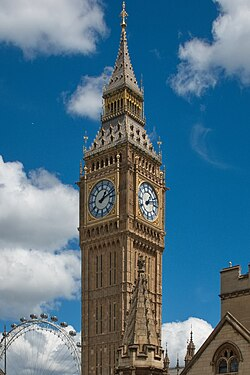Imagine the clock tower is in a different time period, how would it look? Imagine the clock tower in a steampunk alternate universe of the Victorian era. The tower and its surroundings would be adorned with additional mechanical components such as large, ornate cogs and gears exposed on the exterior. Brass and copper piping would wrap around the tower, allowing steam to vent theatrically from the top. The clock faces would be backed by intricate, moving gears, visibly turning in perfect harmony. Instead of a single spire, multiple smaller spires would include rotating wind turbines and static telescopes, bringing a mixture of ancient architecture and futuristic technology to life. 